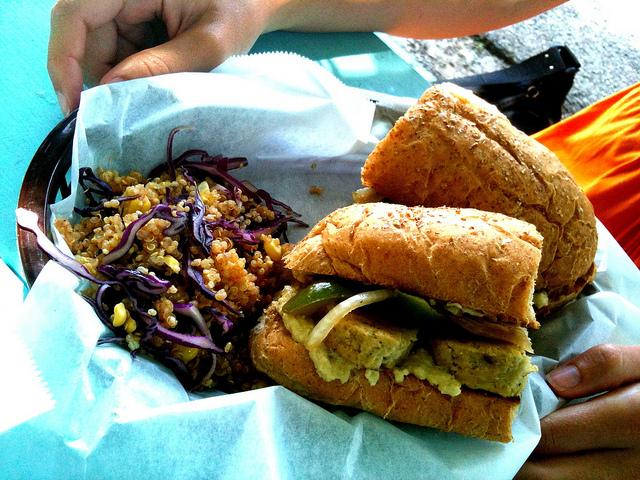What type of food is shown?

Choices:
A) soup
B) fruit
C) sandwiches
D) donuts sandwiches 